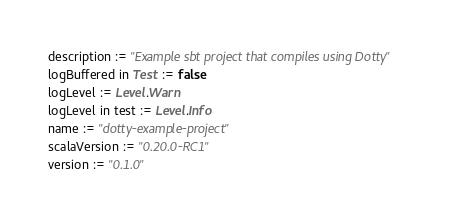Convert code to text. <code><loc_0><loc_0><loc_500><loc_500><_Scala_>description := "Example sbt project that compiles using Dotty"
logBuffered in Test := false
logLevel := Level.Warn
logLevel in test := Level.Info
name := "dotty-example-project"
scalaVersion := "0.20.0-RC1"
version := "0.1.0"
</code> 